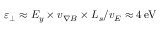Convert formula to latex. <formula><loc_0><loc_0><loc_500><loc_500>\varepsilon _ { \perp } \approx E _ { y } \times v _ { \nabla B } \times L _ { s } / v _ { E } \approx 4 \, e V</formula> 